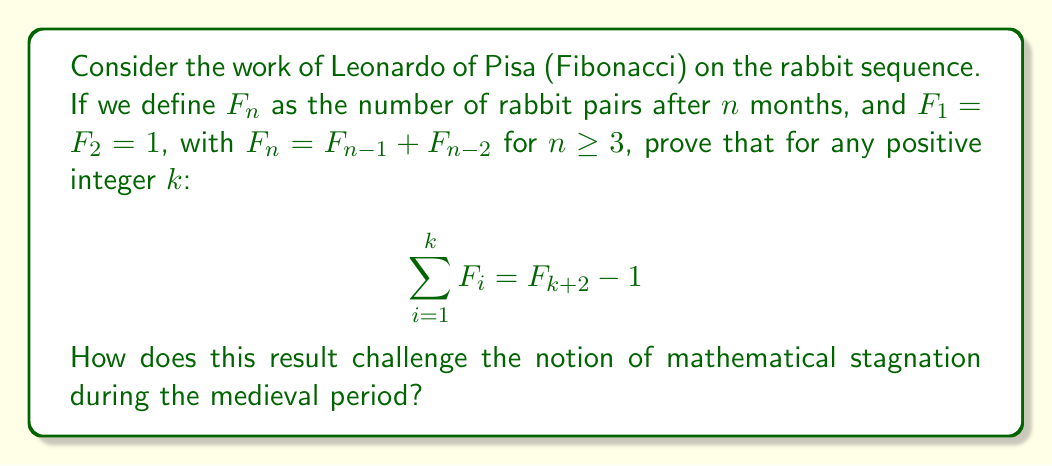Can you answer this question? To prove this identity, we'll use mathematical induction, a technique that was well-known to medieval scholars:

Base case: For $k = 1$,
Left-hand side (LHS): $\sum_{i=1}^1 F_i = F_1 = 1$
Right-hand side (RHS): $F_{1+2} - 1 = F_3 - 1 = 2 - 1 = 1$
So, the base case holds.

Inductive step: Assume the identity holds for some positive integer $k$. We need to prove it holds for $k+1$.

LHS for $k+1$: $\sum_{i=1}^{k+1} F_i = (\sum_{i=1}^k F_i) + F_{k+1}$

Using the inductive hypothesis:
$= (F_{k+2} - 1) + F_{k+1}$

Now, recall the Fibonacci recurrence: $F_{k+3} = F_{k+2} + F_{k+1}$
So, $F_{k+2} + F_{k+1} = F_{k+3}$

Therefore, LHS $= F_{k+3} - 1 = F_{(k+1)+2} - 1$, which is exactly the RHS for $k+1$.

By the principle of mathematical induction, the identity holds for all positive integers $k$.

This result challenges the notion of mathematical stagnation during the medieval period in several ways:

1. Sophistication: The Fibonacci sequence demonstrates advanced mathematical thinking, combining number theory and recursive relationships.

2. Proof techniques: The use of mathematical induction shows that medieval scholars were capable of rigorous proof methods.

3. Abstraction: The ability to generalize patterns and create algebraic identities indicates a high level of mathematical abstraction.

4. Practical applications: The rabbit problem that led to the Fibonacci sequence shows how medieval mathematicians linked abstract concepts to real-world scenarios.

5. Foundation for future work: This sequence and related identities laid groundwork for important developments in mathematics, including the golden ratio and modern combinatorics.
Answer: The identity $\sum_{i=1}^k F_i = F_{k+2} - 1$ is proven for all positive integers $k$. This result, derived from Fibonacci's work, demonstrates sophisticated mathematical thinking, rigorous proof techniques, high-level abstraction, practical problem-solving, and foundational contributions to future mathematical developments, thereby challenging the notion of a "Dark Age" in medieval mathematics. 